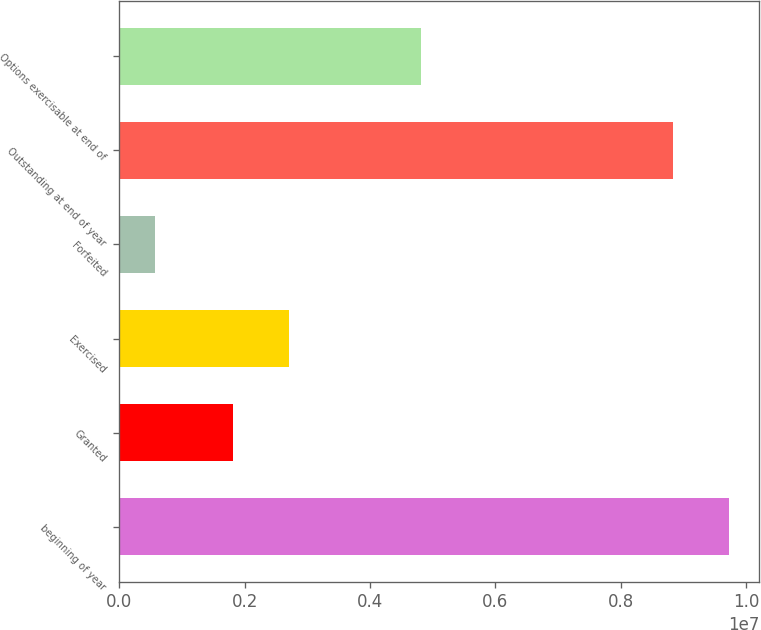Convert chart to OTSL. <chart><loc_0><loc_0><loc_500><loc_500><bar_chart><fcel>beginning of year<fcel>Granted<fcel>Exercised<fcel>Forfeited<fcel>Outstanding at end of year<fcel>Options exercisable at end of<nl><fcel>9.72561e+06<fcel>1.82047e+06<fcel>2.71338e+06<fcel>561336<fcel>8.83271e+06<fcel>4.81316e+06<nl></chart> 